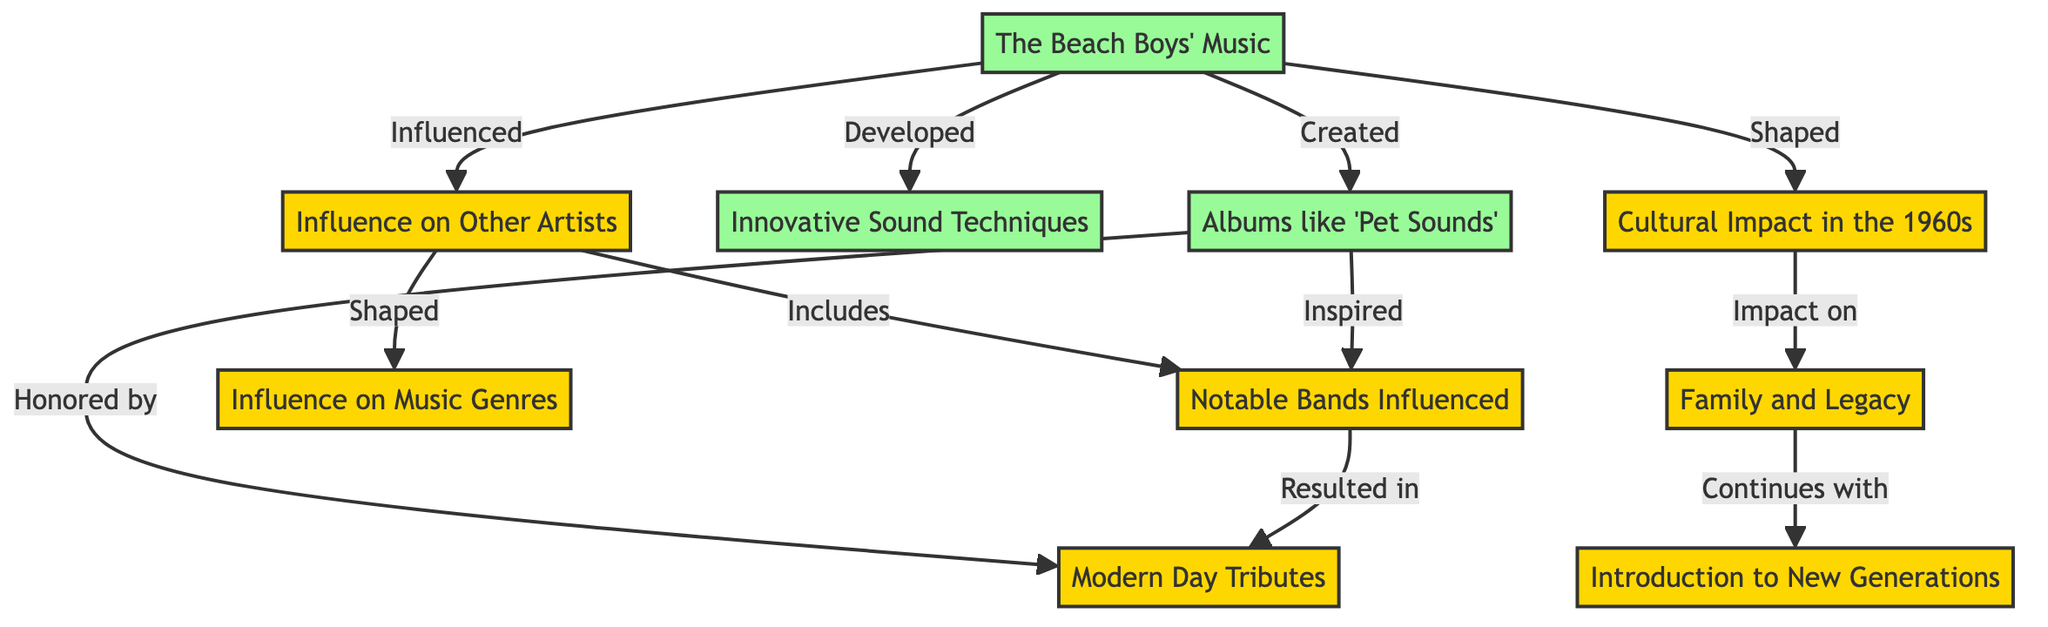What is the title of the concept map? The title of the concept map is provided as "The Beach Boys' Impact on Pop Culture and Other Artists." This is directly stated in the data provided for the diagram.
Answer: The Beach Boys' Impact on Pop Culture and Other Artists How many nodes are in the diagram? To answer this, we count the number of unique items listed under "nodes". There are 10 nodes in total.
Answer: 10 What relationship does "The Beach Boys' Music" have with "Influence on Other Artists"? The edge between "The Beach Boys' Music" and "Influence on Other Artists" is labeled "Influenced", indicating that the former has influenced the latter.
Answer: Influenced Which album is mentioned in the diagram as a significant work? The album specified in the diagram as a notable work is "Pet Sounds". This can be found under the "Albums" node.
Answer: Pet Sounds What are "Notable Bands Influenced" a subset of? "Notable Bands Influenced" is a subset of the "Influence on Other Artists" node, as indicated by the edge marked "Includes."
Answer: Influence on Other Artists How does "Cultural Impact in the 1960s" relate to "Family and Legacy"? "Cultural Impact in the 1960s" is linked to "Family and Legacy" with the edge labeled "Impact on," showing that their cultural impact affected their family and legacy.
Answer: Impact on What continues with the "Family and Legacy"? According to the diagram, what continues with "Family and Legacy" is "Introduction to New Generations," as shown by the edge labeled "Continues with."
Answer: Introduction to New Generations Which two nodes are connected by the edge labeled "Honored by"? The edge labeled "Honored by" connects "Albums like 'Pet Sounds'" to "Modern Day Tributes," showing that the albums have been honored by modern tributes.
Answer: Modern Day Tributes What do the "Innovative Sound Techniques" contribute to? "Innovative Sound Techniques" is described as something that "Developed" from "The Beach Boys' Music," showing that the music contributed to these sound techniques.
Answer: Developed 